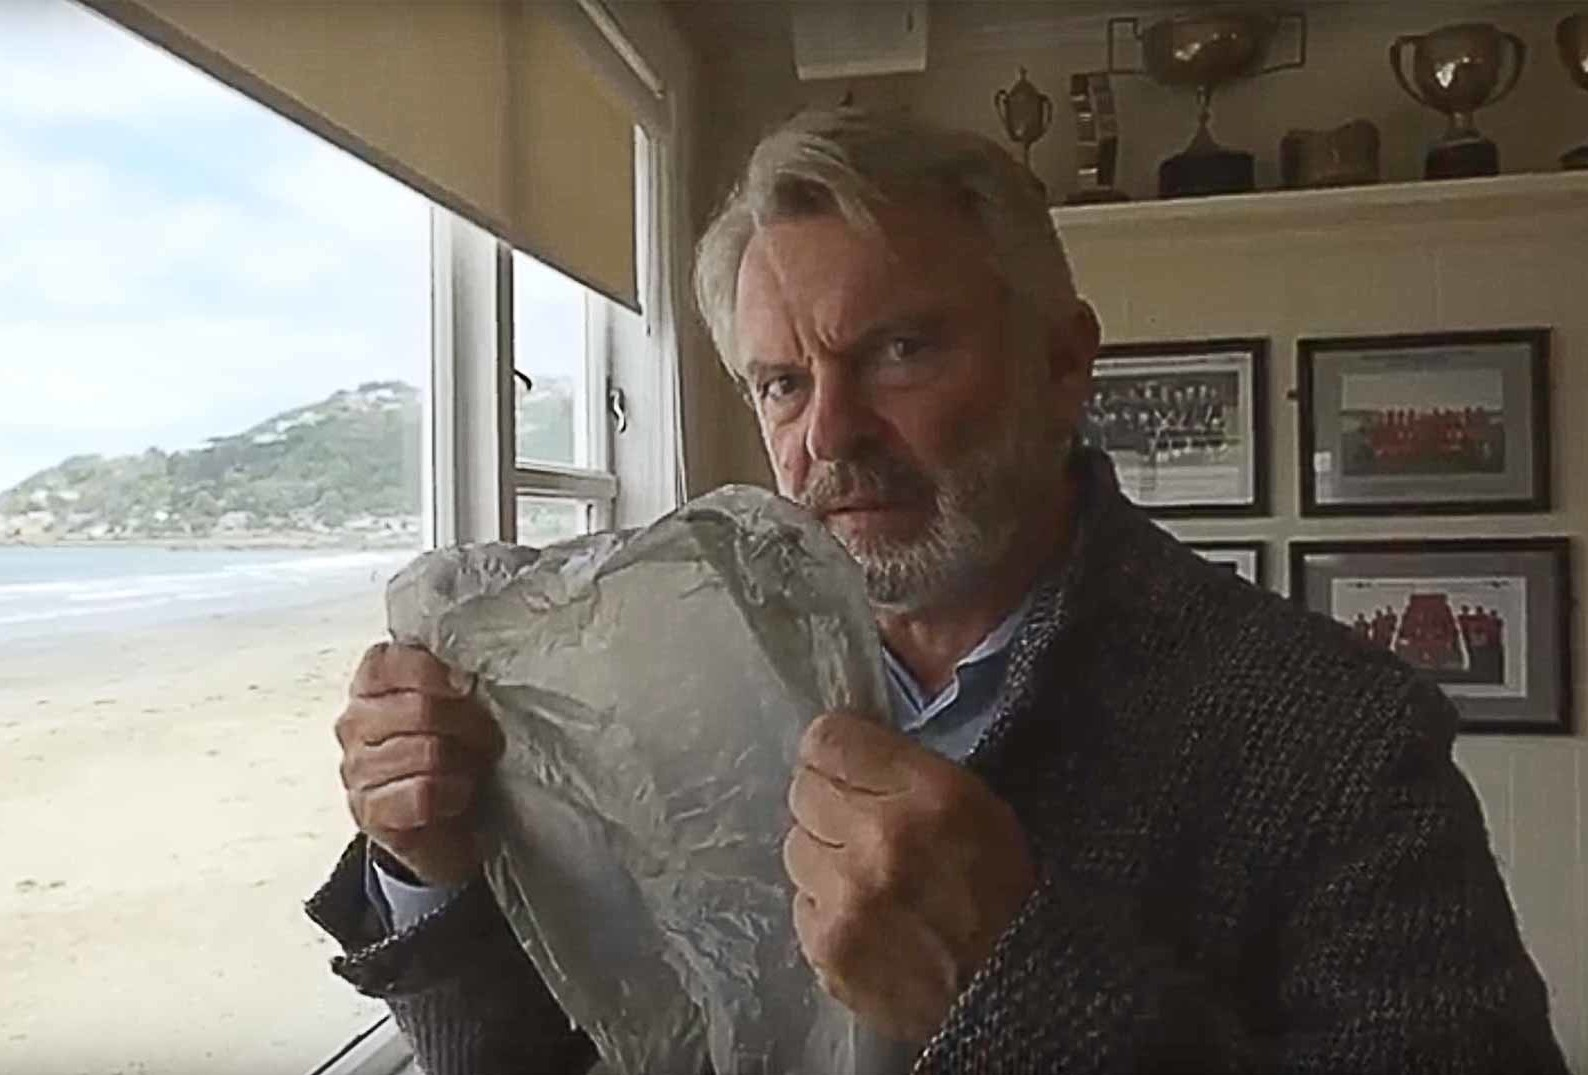What significance might the piece of aluminum foil have in this context? The piece of crumpled aluminum foil, which he holds prominently, could be intriguingly symbolic. It might represent something he is working on, perhaps related to an artistic project, or it could be a prop from a recent endeavor. The prominent display and his contemplative look suggest it holds some significance, either as a tool or as a metaphorical element in a larger narrative or project he is involved in. 